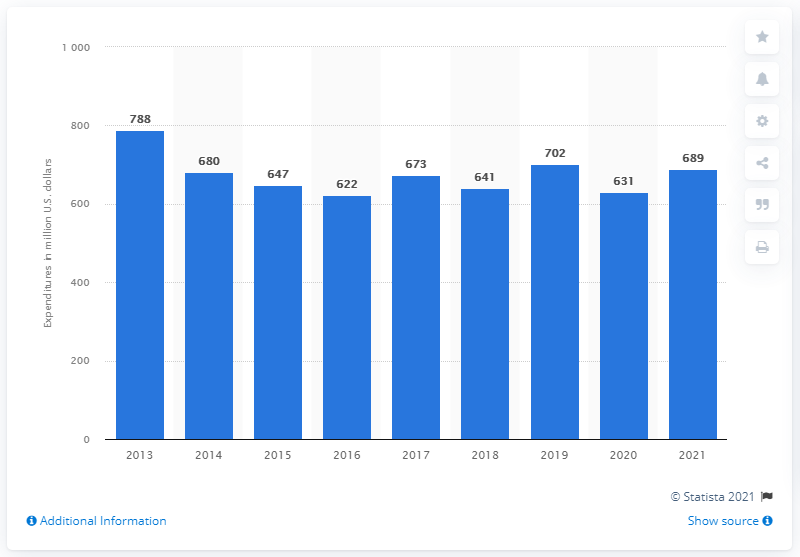Specify some key components in this picture. Electronic Arts spent approximately 689 million U.S. dollars on marketing and sales in 2021. 